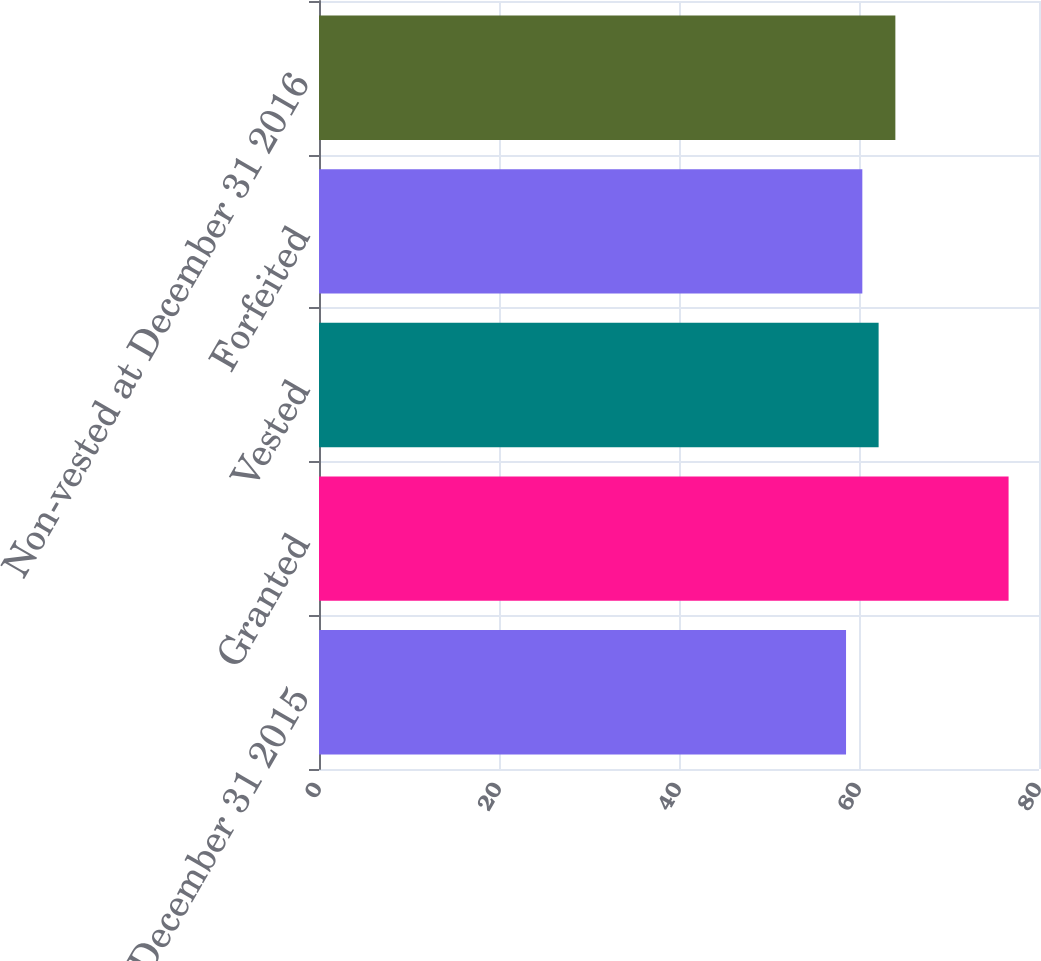Convert chart. <chart><loc_0><loc_0><loc_500><loc_500><bar_chart><fcel>Non-vested at December 31 2015<fcel>Granted<fcel>Vested<fcel>Forfeited<fcel>Non-vested at December 31 2016<nl><fcel>58.56<fcel>76.62<fcel>62.18<fcel>60.37<fcel>64.04<nl></chart> 